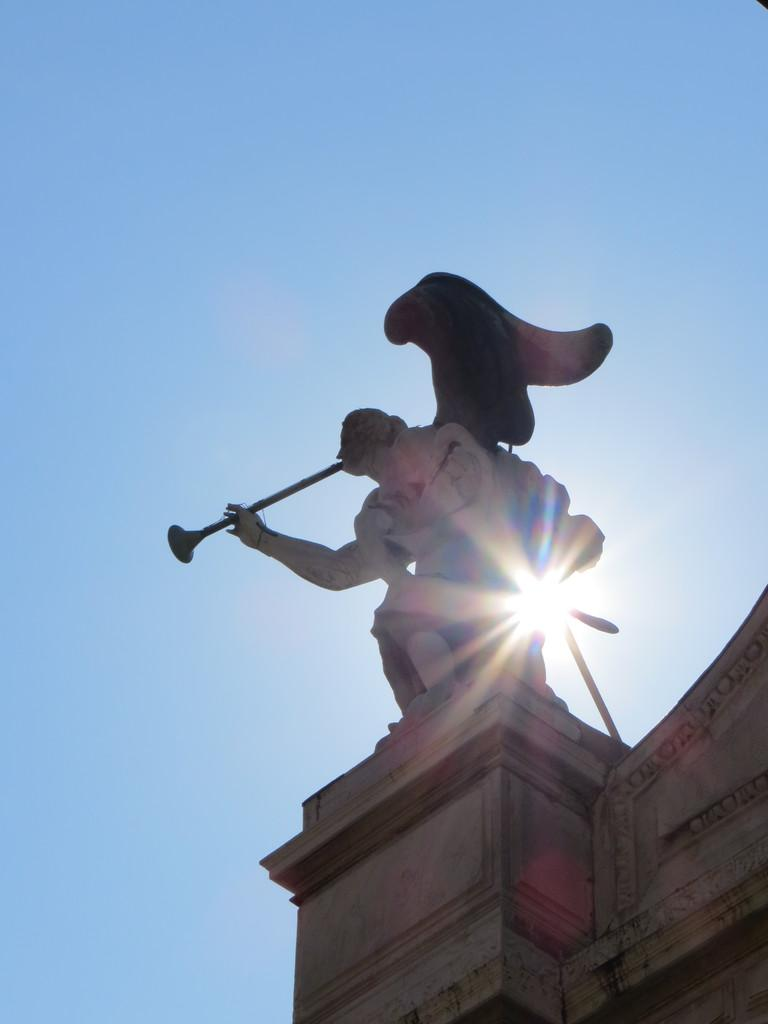What is located on the top of the building in the image? There is a statue on the top of the building in the image. What color is the sky in the image? The sky is blue in the image. What type of vegetable is being used as a badge in the image? There is no vegetable or badge present in the image. 